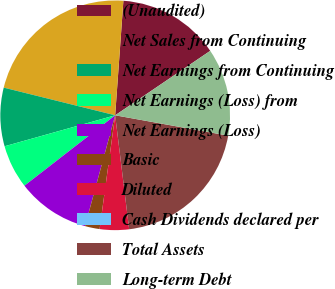<chart> <loc_0><loc_0><loc_500><loc_500><pie_chart><fcel>(Unaudited)<fcel>Net Sales from Continuing<fcel>Net Earnings from Continuing<fcel>Net Earnings (Loss) from<fcel>Net Earnings (Loss)<fcel>Basic<fcel>Diluted<fcel>Cash Dividends declared per<fcel>Total Assets<fcel>Long-term Debt<nl><fcel>14.38%<fcel>22.27%<fcel>8.22%<fcel>6.16%<fcel>10.27%<fcel>2.06%<fcel>4.11%<fcel>0.0%<fcel>20.22%<fcel>12.32%<nl></chart> 